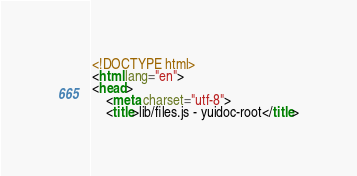<code> <loc_0><loc_0><loc_500><loc_500><_HTML_><!DOCTYPE html>
<html lang="en">
<head>
    <meta charset="utf-8">
    <title>lib/files.js - yuidoc-root</title></code> 